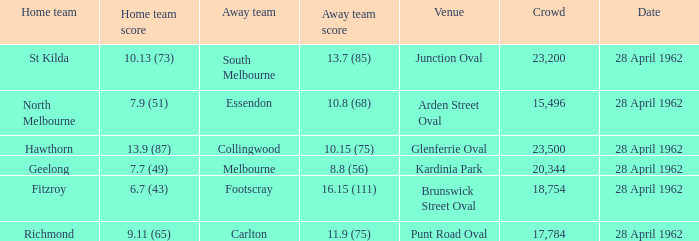What was the crowd size when there was a home team score of 10.13 (73)? 23200.0. 